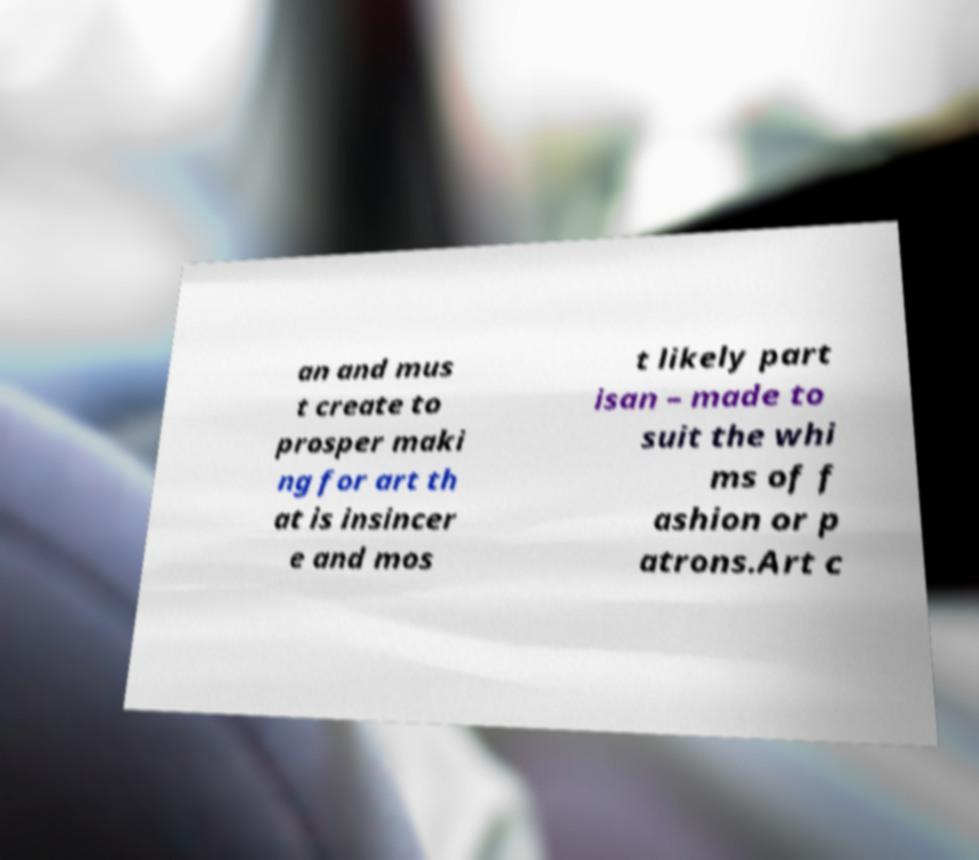Can you read and provide the text displayed in the image?This photo seems to have some interesting text. Can you extract and type it out for me? an and mus t create to prosper maki ng for art th at is insincer e and mos t likely part isan – made to suit the whi ms of f ashion or p atrons.Art c 